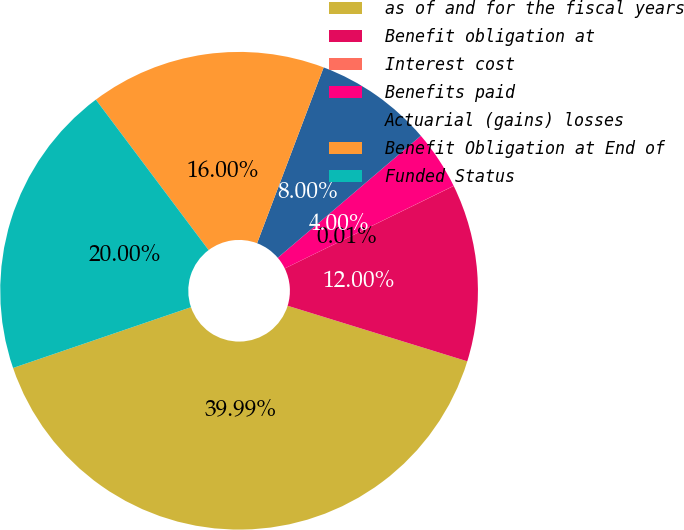Convert chart to OTSL. <chart><loc_0><loc_0><loc_500><loc_500><pie_chart><fcel>as of and for the fiscal years<fcel>Benefit obligation at<fcel>Interest cost<fcel>Benefits paid<fcel>Actuarial (gains) losses<fcel>Benefit Obligation at End of<fcel>Funded Status<nl><fcel>39.99%<fcel>12.0%<fcel>0.01%<fcel>4.0%<fcel>8.0%<fcel>16.0%<fcel>20.0%<nl></chart> 